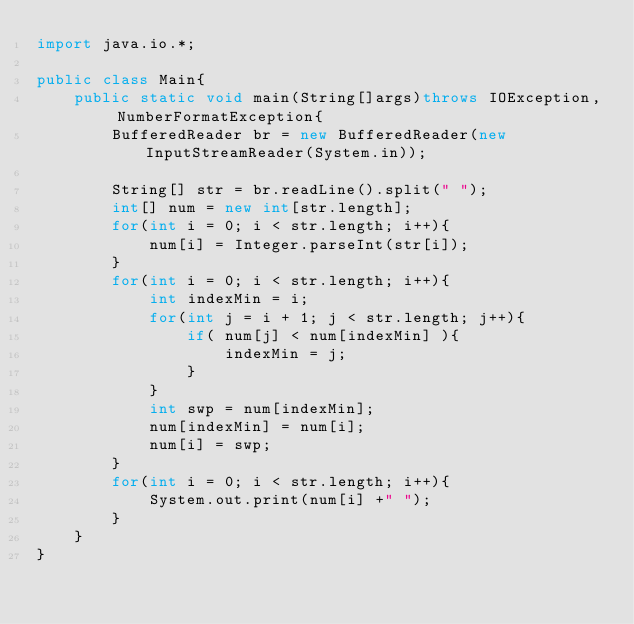<code> <loc_0><loc_0><loc_500><loc_500><_Java_>import java.io.*;

public class Main{
    public static void main(String[]args)throws IOException, NumberFormatException{
        BufferedReader br = new BufferedReader(new InputStreamReader(System.in));

        String[] str = br.readLine().split(" ");
        int[] num = new int[str.length];
        for(int i = 0; i < str.length; i++){
            num[i] = Integer.parseInt(str[i]);
        }
        for(int i = 0; i < str.length; i++){
            int indexMin = i;
            for(int j = i + 1; j < str.length; j++){
                if( num[j] < num[indexMin] ){
                    indexMin = j;
                }
            }
            int swp = num[indexMin];
            num[indexMin] = num[i];
            num[i] = swp;
        }
        for(int i = 0; i < str.length; i++){
            System.out.print(num[i] +" ");
        }
    }
}</code> 